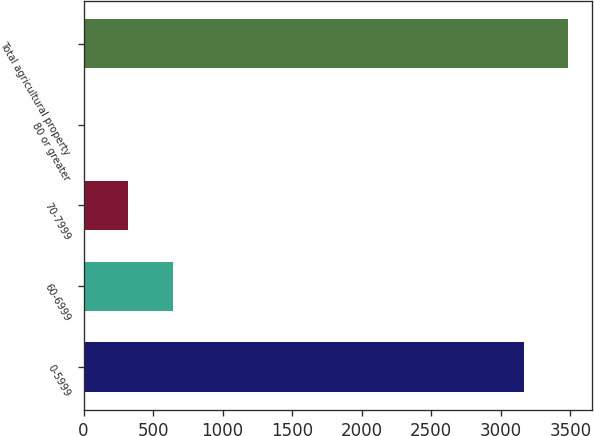<chart> <loc_0><loc_0><loc_500><loc_500><bar_chart><fcel>0-5999<fcel>60-6999<fcel>70-7999<fcel>80 or greater<fcel>Total agricultural property<nl><fcel>3163<fcel>641.51<fcel>321.32<fcel>1.13<fcel>3483.19<nl></chart> 